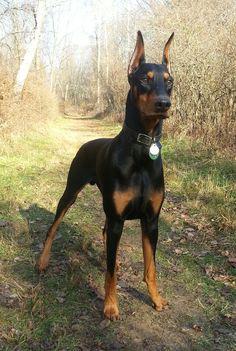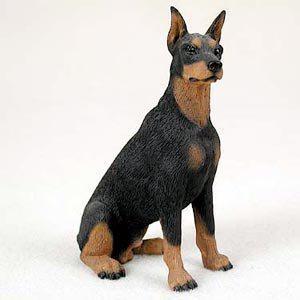The first image is the image on the left, the second image is the image on the right. Given the left and right images, does the statement "One of the dogs has floppy ears." hold true? Answer yes or no. No. The first image is the image on the left, the second image is the image on the right. For the images shown, is this caption "There is a young puppy in one image." true? Answer yes or no. No. 